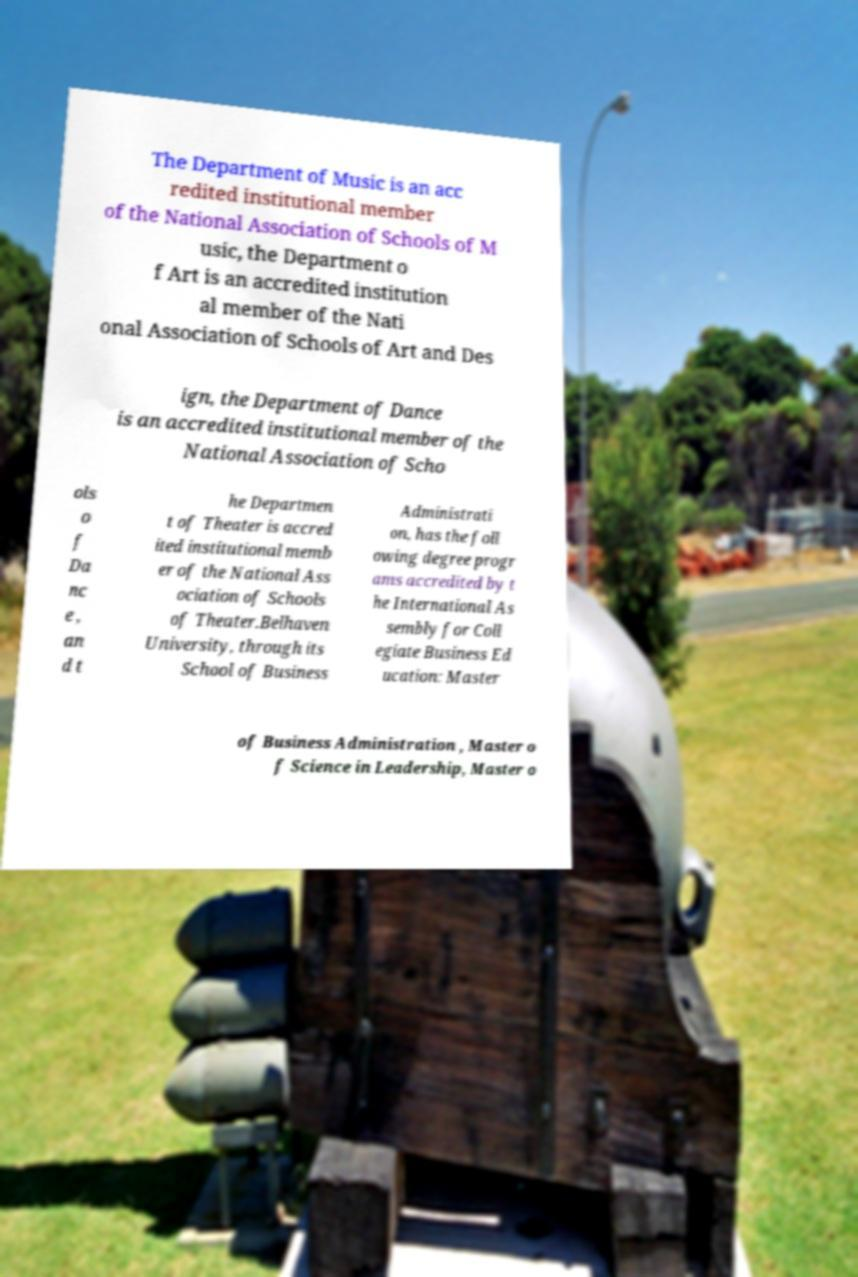I need the written content from this picture converted into text. Can you do that? The Department of Music is an acc redited institutional member of the National Association of Schools of M usic, the Department o f Art is an accredited institution al member of the Nati onal Association of Schools of Art and Des ign, the Department of Dance is an accredited institutional member of the National Association of Scho ols o f Da nc e , an d t he Departmen t of Theater is accred ited institutional memb er of the National Ass ociation of Schools of Theater.Belhaven University, through its School of Business Administrati on, has the foll owing degree progr ams accredited by t he International As sembly for Coll egiate Business Ed ucation: Master of Business Administration , Master o f Science in Leadership, Master o 